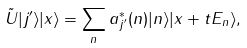Convert formula to latex. <formula><loc_0><loc_0><loc_500><loc_500>\tilde { U } | j ^ { \prime } \rangle | x \rangle = \sum _ { n } a ^ { * } _ { j ^ { \prime } } ( n ) | n \rangle | x + t E _ { n } \rangle ,</formula> 